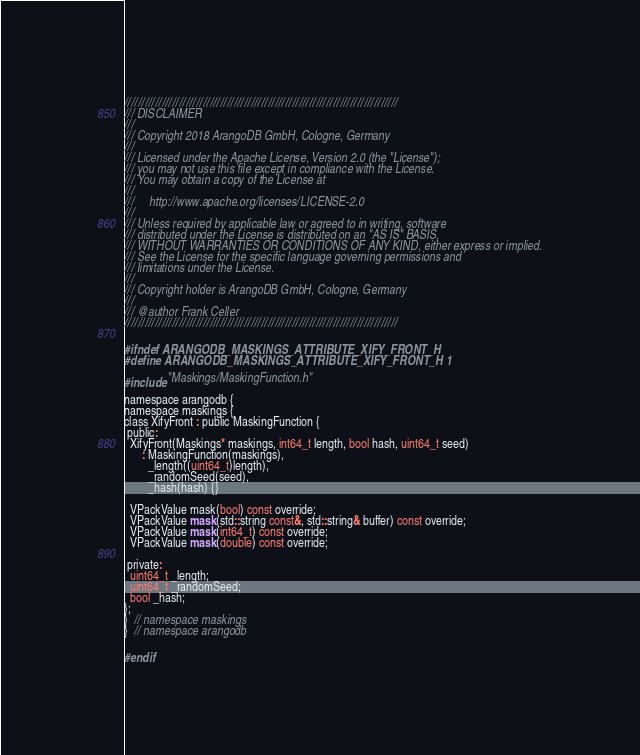Convert code to text. <code><loc_0><loc_0><loc_500><loc_500><_C_>////////////////////////////////////////////////////////////////////////////////
/// DISCLAIMER
///
/// Copyright 2018 ArangoDB GmbH, Cologne, Germany
///
/// Licensed under the Apache License, Version 2.0 (the "License");
/// you may not use this file except in compliance with the License.
/// You may obtain a copy of the License at
///
///     http://www.apache.org/licenses/LICENSE-2.0
///
/// Unless required by applicable law or agreed to in writing, software
/// distributed under the License is distributed on an "AS IS" BASIS,
/// WITHOUT WARRANTIES OR CONDITIONS OF ANY KIND, either express or implied.
/// See the License for the specific language governing permissions and
/// limitations under the License.
///
/// Copyright holder is ArangoDB GmbH, Cologne, Germany
///
/// @author Frank Celler
////////////////////////////////////////////////////////////////////////////////

#ifndef ARANGODB_MASKINGS_ATTRIBUTE_XIFY_FRONT_H
#define ARANGODB_MASKINGS_ATTRIBUTE_XIFY_FRONT_H 1

#include "Maskings/MaskingFunction.h"

namespace arangodb {
namespace maskings {
class XifyFront : public MaskingFunction {
 public:
  XifyFront(Maskings* maskings, int64_t length, bool hash, uint64_t seed)
      : MaskingFunction(maskings),
        _length((uint64_t)length),
        _randomSeed(seed),
        _hash(hash) {}

  VPackValue mask(bool) const override;
  VPackValue mask(std::string const&, std::string& buffer) const override;
  VPackValue mask(int64_t) const override;
  VPackValue mask(double) const override;

 private:
  uint64_t _length;
  uint64_t _randomSeed;
  bool _hash;
};
}  // namespace maskings
}  // namespace arangodb

#endif
</code> 